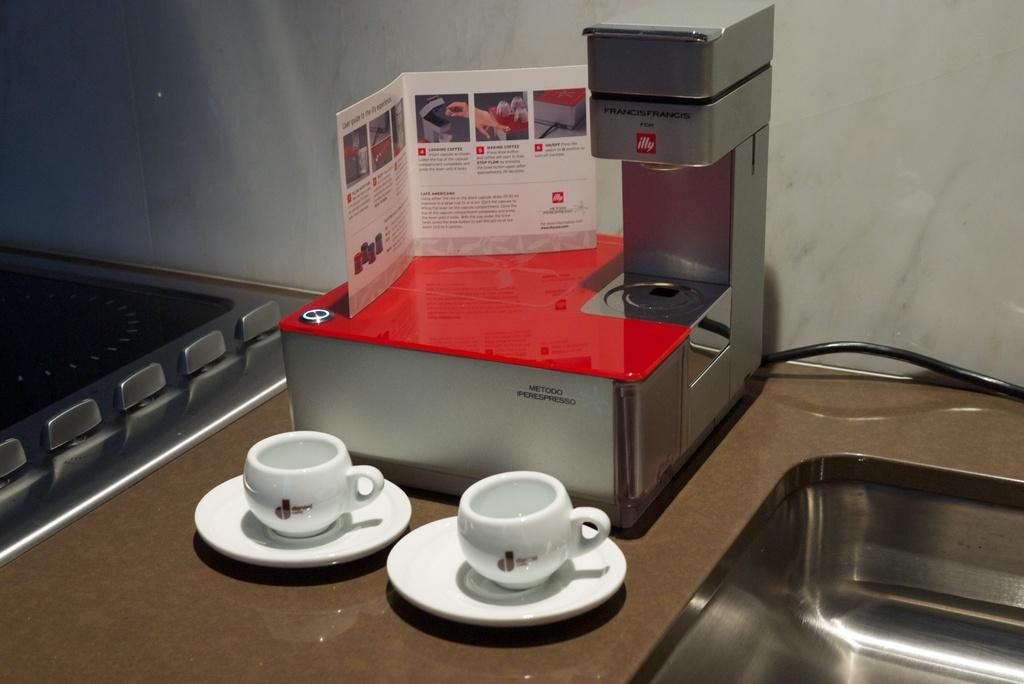What is the main piece of furniture in the image? There is a table in the image. What items can be seen on the table? There are cups, saucers, a sink, a coffee maker, paper, and an induction stove on the table. What is the purpose of the sink on the table? The sink on the table is likely used for washing or rinsing items. What can be seen in the background of the image? There is a wall in the background of the image. How many pigs are visible in the image? There are no pigs present in the image. What type of collar is being worn by the yoke in the image? There is no yoke or collar present in the image. 